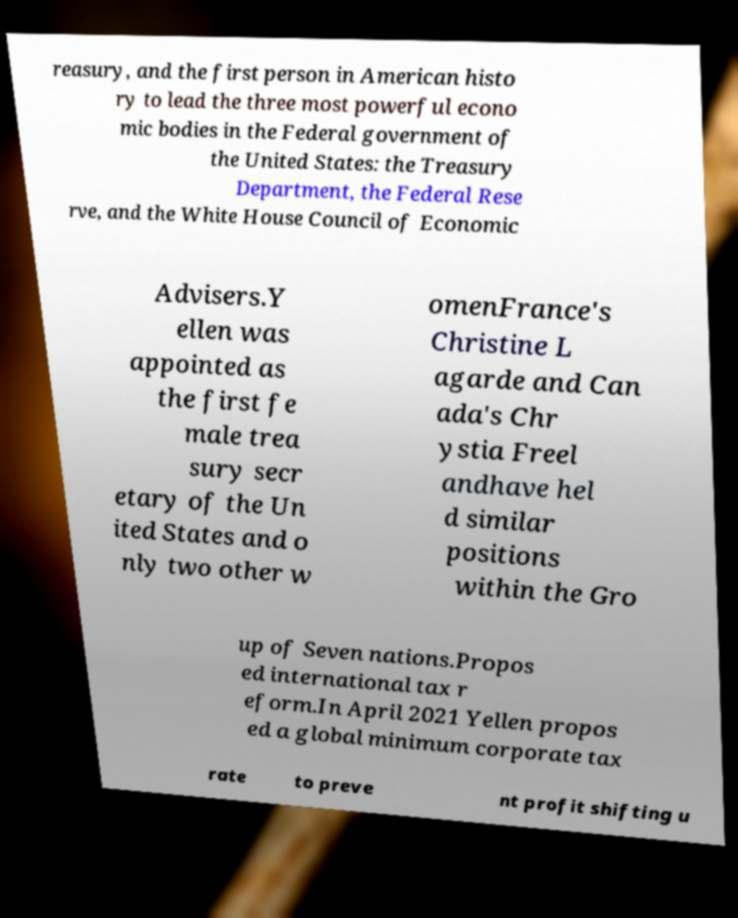Can you accurately transcribe the text from the provided image for me? reasury, and the first person in American histo ry to lead the three most powerful econo mic bodies in the Federal government of the United States: the Treasury Department, the Federal Rese rve, and the White House Council of Economic Advisers.Y ellen was appointed as the first fe male trea sury secr etary of the Un ited States and o nly two other w omenFrance's Christine L agarde and Can ada's Chr ystia Freel andhave hel d similar positions within the Gro up of Seven nations.Propos ed international tax r eform.In April 2021 Yellen propos ed a global minimum corporate tax rate to preve nt profit shifting u 